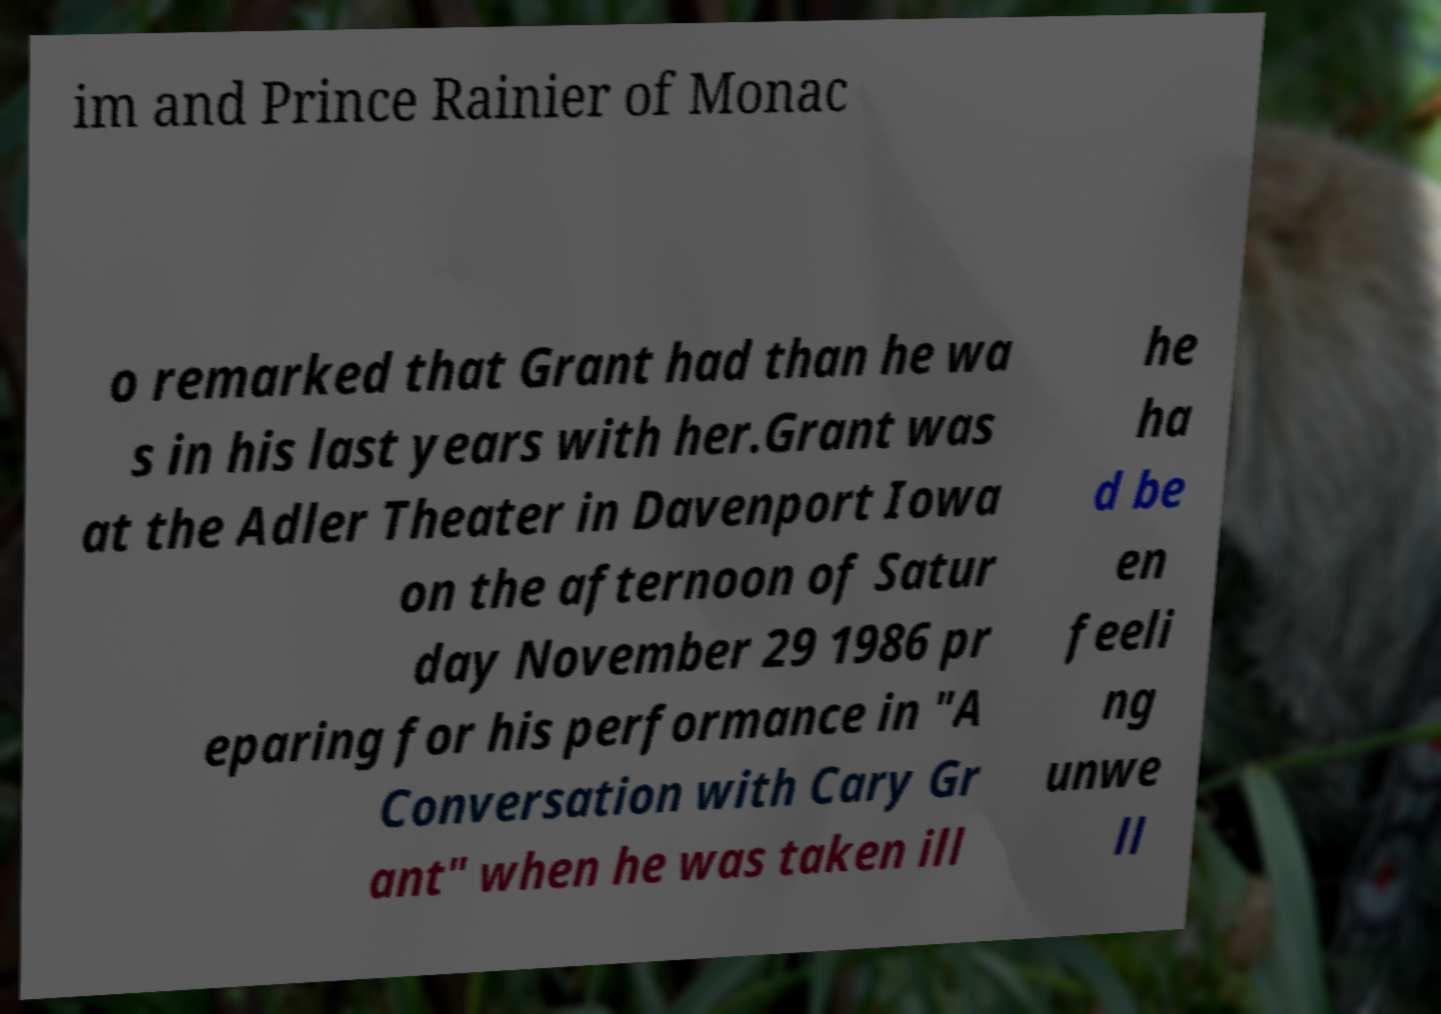For documentation purposes, I need the text within this image transcribed. Could you provide that? im and Prince Rainier of Monac o remarked that Grant had than he wa s in his last years with her.Grant was at the Adler Theater in Davenport Iowa on the afternoon of Satur day November 29 1986 pr eparing for his performance in "A Conversation with Cary Gr ant" when he was taken ill he ha d be en feeli ng unwe ll 